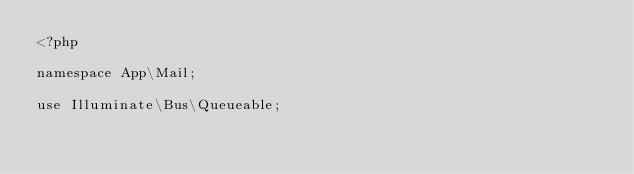<code> <loc_0><loc_0><loc_500><loc_500><_PHP_><?php

namespace App\Mail;

use Illuminate\Bus\Queueable;</code> 